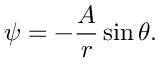Convert formula to latex. <formula><loc_0><loc_0><loc_500><loc_500>\psi = - { \frac { A } { r } } \sin \theta .</formula> 